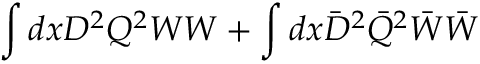Convert formula to latex. <formula><loc_0><loc_0><loc_500><loc_500>\int { d x D ^ { 2 } Q ^ { 2 } } W W + \int { d x \bar { D } ^ { 2 } \bar { Q } ^ { 2 } } \bar { W } \bar { W }</formula> 